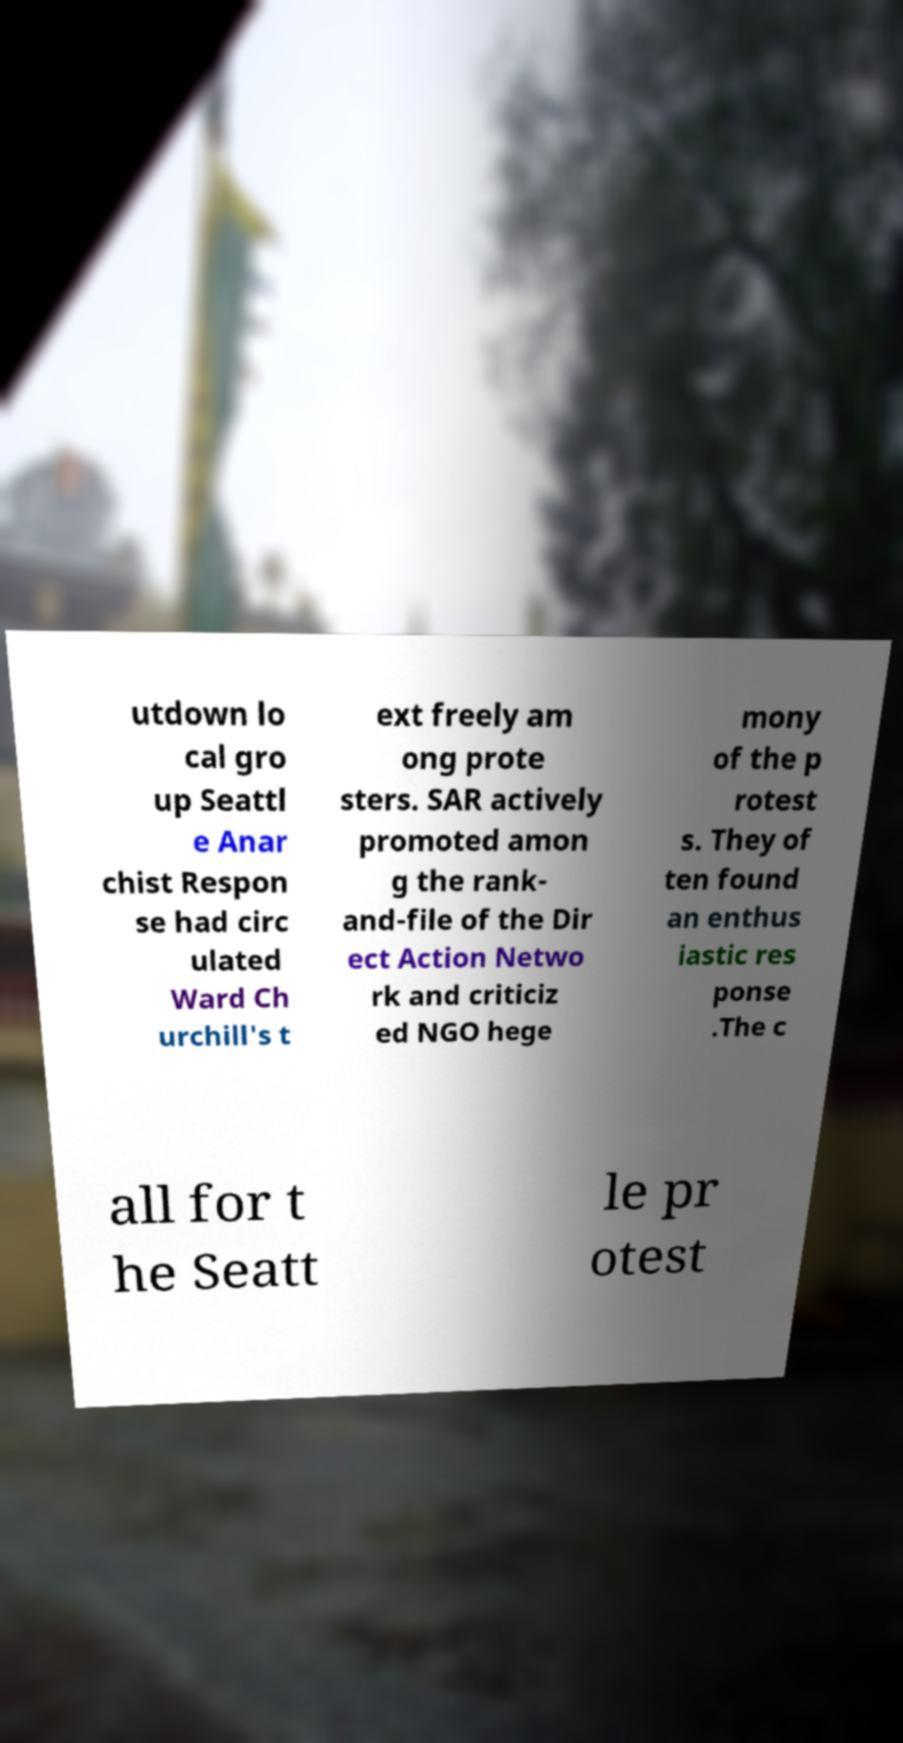Can you read and provide the text displayed in the image?This photo seems to have some interesting text. Can you extract and type it out for me? utdown lo cal gro up Seattl e Anar chist Respon se had circ ulated Ward Ch urchill's t ext freely am ong prote sters. SAR actively promoted amon g the rank- and-file of the Dir ect Action Netwo rk and criticiz ed NGO hege mony of the p rotest s. They of ten found an enthus iastic res ponse .The c all for t he Seatt le pr otest 